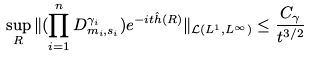Convert formula to latex. <formula><loc_0><loc_0><loc_500><loc_500>\sup _ { R } \| ( \prod _ { i = 1 } ^ { n } D ^ { \gamma _ { i } } _ { m _ { i } , s _ { i } } ) e ^ { - i t \hat { h } ( R ) } \| _ { \mathcal { L } ( L ^ { 1 } , L ^ { \infty } ) } \leq \frac { C _ { \gamma } } { t ^ { 3 / 2 } }</formula> 